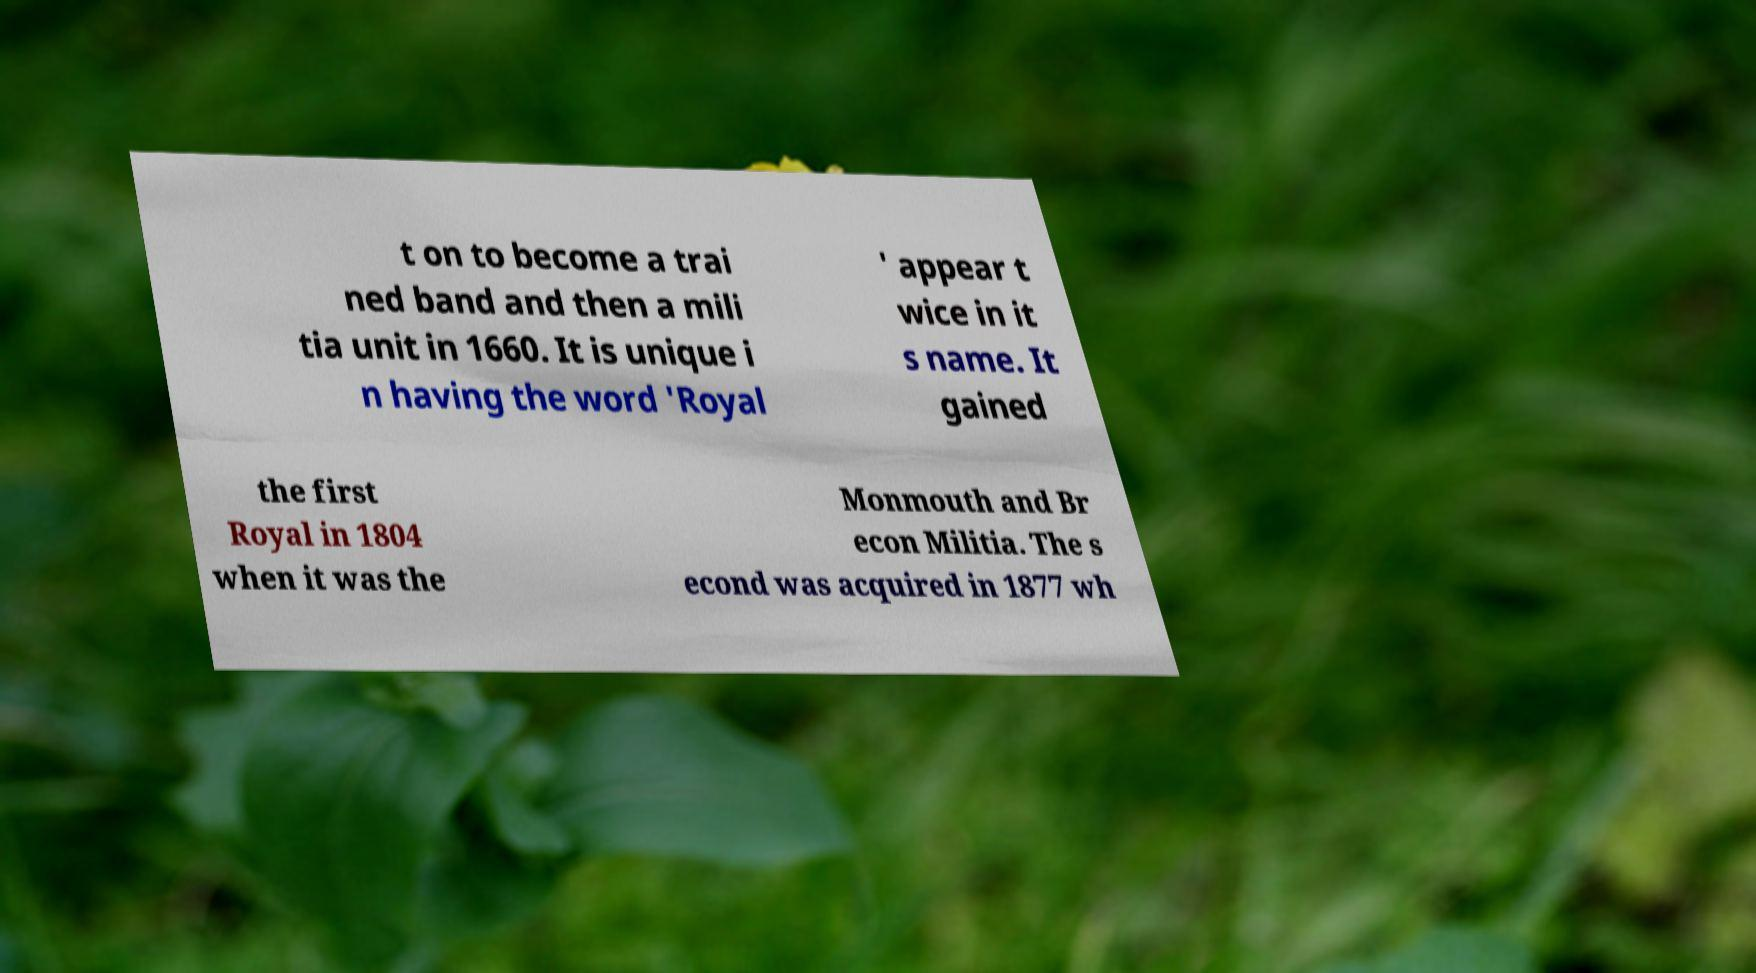Could you extract and type out the text from this image? t on to become a trai ned band and then a mili tia unit in 1660. It is unique i n having the word 'Royal ' appear t wice in it s name. It gained the first Royal in 1804 when it was the Monmouth and Br econ Militia. The s econd was acquired in 1877 wh 